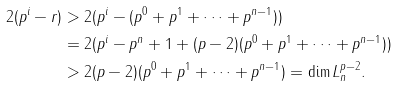<formula> <loc_0><loc_0><loc_500><loc_500>2 ( p ^ { i } - r ) & > 2 ( p ^ { i } - ( p ^ { 0 } + p ^ { 1 } + \dots + p ^ { n - 1 } ) ) \\ & = 2 ( p ^ { i } - p ^ { n } + 1 + ( p - 2 ) ( p ^ { 0 } + p ^ { 1 } + \dots + p ^ { n - 1 } ) ) \\ & > 2 ( p - 2 ) ( p ^ { 0 } + p ^ { 1 } + \dots + p ^ { n - 1 } ) = \dim L _ { n } ^ { p - 2 } .</formula> 